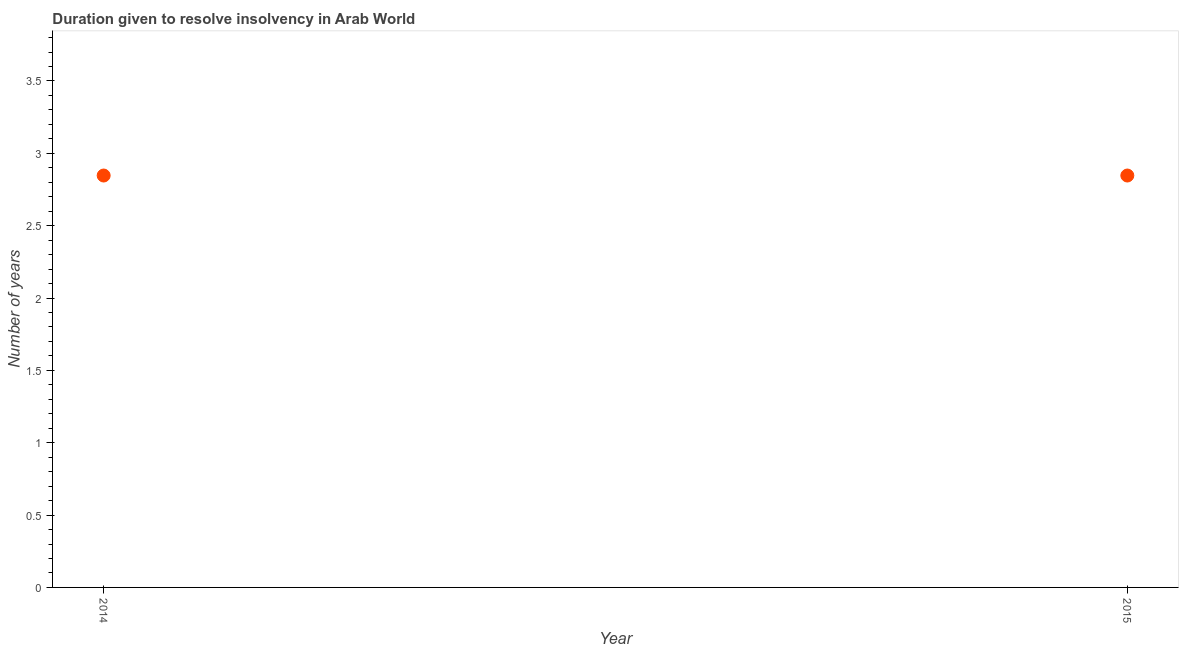What is the number of years to resolve insolvency in 2014?
Make the answer very short. 2.85. Across all years, what is the maximum number of years to resolve insolvency?
Offer a terse response. 2.85. Across all years, what is the minimum number of years to resolve insolvency?
Your answer should be very brief. 2.85. In which year was the number of years to resolve insolvency minimum?
Offer a terse response. 2014. What is the sum of the number of years to resolve insolvency?
Your answer should be very brief. 5.69. What is the difference between the number of years to resolve insolvency in 2014 and 2015?
Make the answer very short. 0. What is the average number of years to resolve insolvency per year?
Your answer should be very brief. 2.85. What is the median number of years to resolve insolvency?
Offer a terse response. 2.85. Do a majority of the years between 2015 and 2014 (inclusive) have number of years to resolve insolvency greater than 1.8 ?
Your answer should be compact. No. What is the ratio of the number of years to resolve insolvency in 2014 to that in 2015?
Offer a terse response. 1. Is the number of years to resolve insolvency in 2014 less than that in 2015?
Your answer should be compact. No. In how many years, is the number of years to resolve insolvency greater than the average number of years to resolve insolvency taken over all years?
Your answer should be compact. 0. How many years are there in the graph?
Provide a short and direct response. 2. What is the title of the graph?
Keep it short and to the point. Duration given to resolve insolvency in Arab World. What is the label or title of the Y-axis?
Your response must be concise. Number of years. What is the Number of years in 2014?
Ensure brevity in your answer.  2.85. What is the Number of years in 2015?
Your answer should be very brief. 2.85. What is the difference between the Number of years in 2014 and 2015?
Provide a short and direct response. 0. 